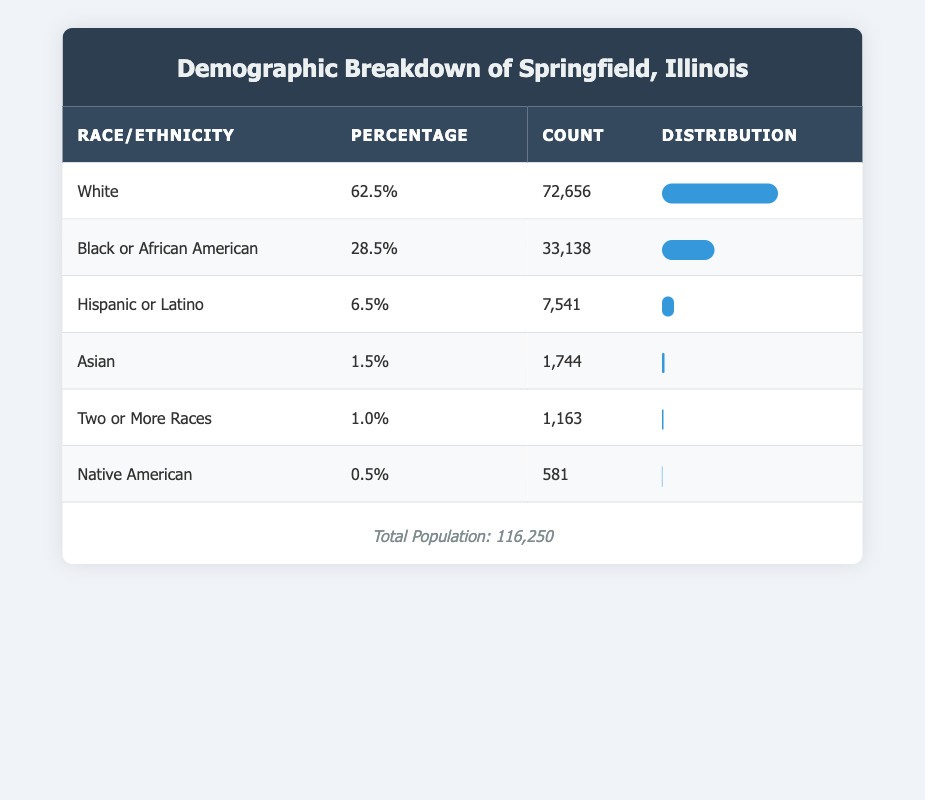What is the percentage of the White population in Springfield? The table directly lists the percentage for the White population as 62.5%.
Answer: 62.5% What is the count of the Hispanic or Latino population? The table shows the count for the Hispanic or Latino population as 7,541.
Answer: 7,541 Is the Asian population less than 2% of the total population? The table indicates that the Asian population is 1.5%, which is indeed less than 2%.
Answer: Yes What is the total count of the Black or African American and White populations combined? To find this, we add the counts of both groups: 72,656 (White) + 33,138 (Black or African American) = 105,794.
Answer: 105,794 What percentage of the population identifies as Two or More Races? The percentage for the Two or More Races group is shown as 1.0% in the table.
Answer: 1.0% What is the difference in percentage between the Black or African American and the White population? The difference is calculated by subtracting the percentage of Black or African American (28.5%) from the percentage of White (62.5%): 62.5% - 28.5% = 34%.
Answer: 34% If you combine the populations of all races except for the Native American group, what percentage is that? First, we calculate the total percentage of the other groups: 62.5% + 28.5% + 6.5% + 1.5% + 1.0% = 100.0%. Thus, subtracting Native American (0.5%) yields 100.0% - 0.5% = 99.5%.
Answer: 99.5% What is the ratio of the Native American population to the Hispanic or Latino population? The counts for Native American and Hispanic or Latino populations are 581 and 7,541, respectively. Thus, the ratio is 581:7,541 which simplifies to approximately 1:13.
Answer: 1:13 